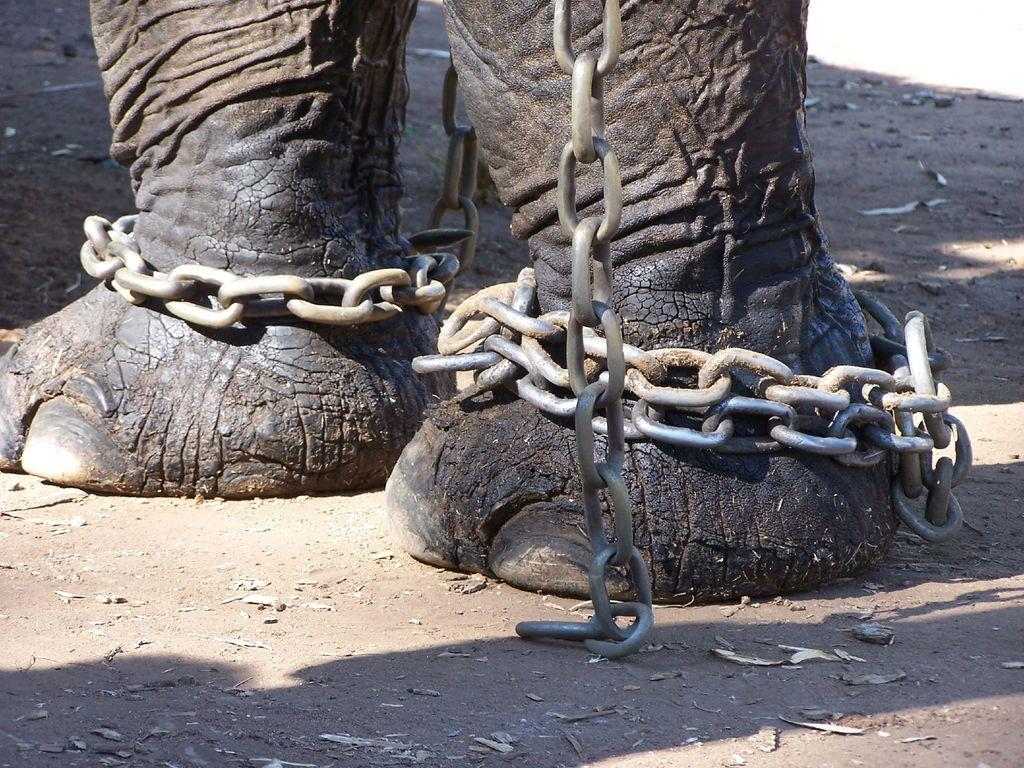What animal is the main subject of the image? There is an elephant in the image. What is attached to the elephant's legs? The elephant has chains on its legs. What type of distribution system is being used by the actor in the image? There is no actor present in the image, and therefore no distribution system can be observed. What is the elephant doing with its mouth in the image? The image does not show the elephant's mouth, so it cannot be determined what the elephant is doing with its mouth. 